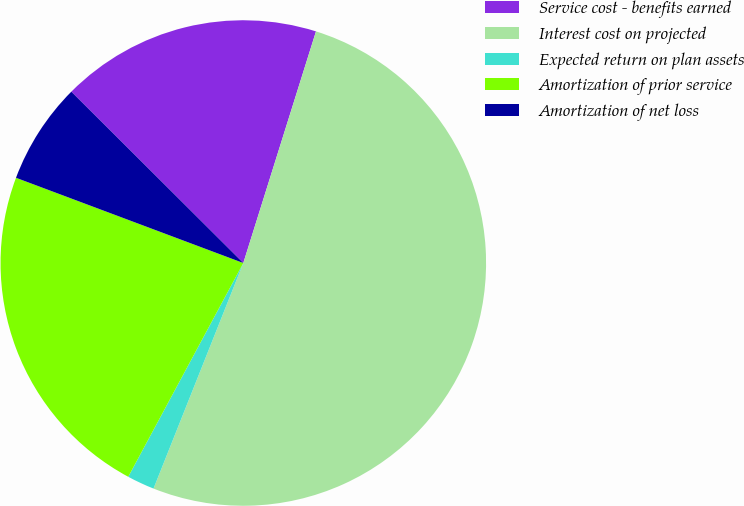<chart> <loc_0><loc_0><loc_500><loc_500><pie_chart><fcel>Service cost - benefits earned<fcel>Interest cost on projected<fcel>Expected return on plan assets<fcel>Amortization of prior service<fcel>Amortization of net loss<nl><fcel>17.37%<fcel>51.19%<fcel>1.83%<fcel>22.85%<fcel>6.76%<nl></chart> 